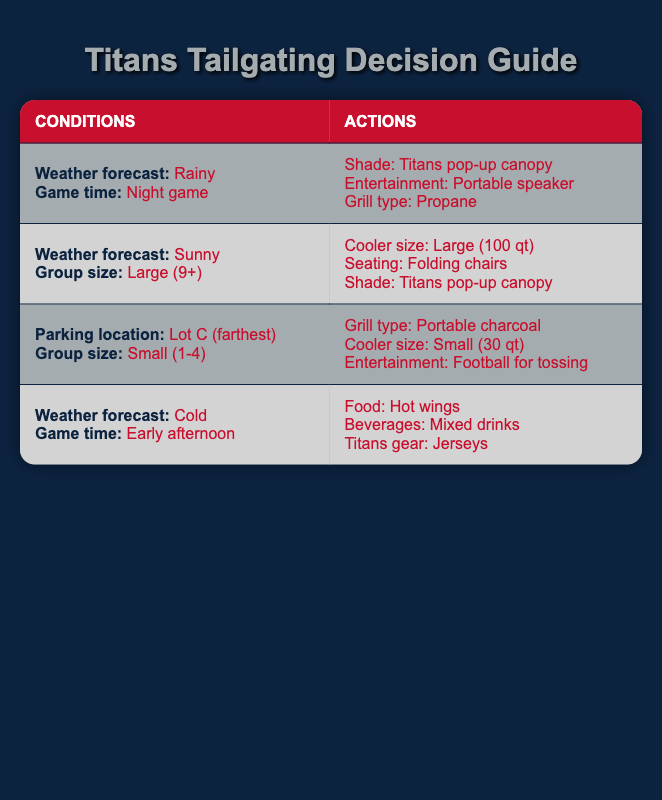What shading equipment should I bring for a rainy night game? According to the table, if the weather forecast is rainy and the game is at night, you should bring a Titans pop-up canopy as the shading equipment.
Answer: Titans pop-up canopy What type of grill is recommended for a small group tailgating in Lot C? For a small group size (1-4 people) tailgating in Lot C (farthest parking), the recommended grill type is portable charcoal.
Answer: Portable charcoal Does sunny weather for a large group require a specific cooler size? Yes, if the weather is sunny and the group size is large (9+), the table suggests bringing a large cooler size of 100 qt.
Answer: Yes What food options are suggested for a cold early afternoon game? The table indicates that for a cold weather forecast during an early afternoon game, the recommended food option is hot wings.
Answer: Hot wings If it's sunny and I have a medium group, what shade option is recommended? The provided table does not specifically address shade options for a sunny day with a medium group size. The condition only specifies large groups requiring the Titans pop-up canopy for shade. Thus, we cannot definitively conclude a recommendation for a medium group.
Answer: Not applicable In total, how many actions are suggested for rain during a night game? For rain during a night game, the table shows three specific actions: the shade is a Titans pop-up canopy, the entertainment is a portable speaker, and the grill type is propane. Therefore, the total number of actions suggested is three.
Answer: 3 Which Titans gear is appropriate for a cold early afternoon? The table clearly states that for a cold weather forecast during an early afternoon game, the gear recommended is jerseys.
Answer: Jerseys Is a portable speaker necessary for tailgating regardless of weather? The table suggests that a portable speaker is specifically recommended for rainy weather during a night game. However, it does not indicate that this equipment is necessary in all weather conditions. Therefore, it's not required regardless of weather.
Answer: No What is the maximum group size mentioned in the table for which portable charcoal is recommended? The table indicates that portable charcoal is recommended for small groups consisting of 1-4 people. Therefore, this is the maximum group size mentioned for that grill type.
Answer: 4 